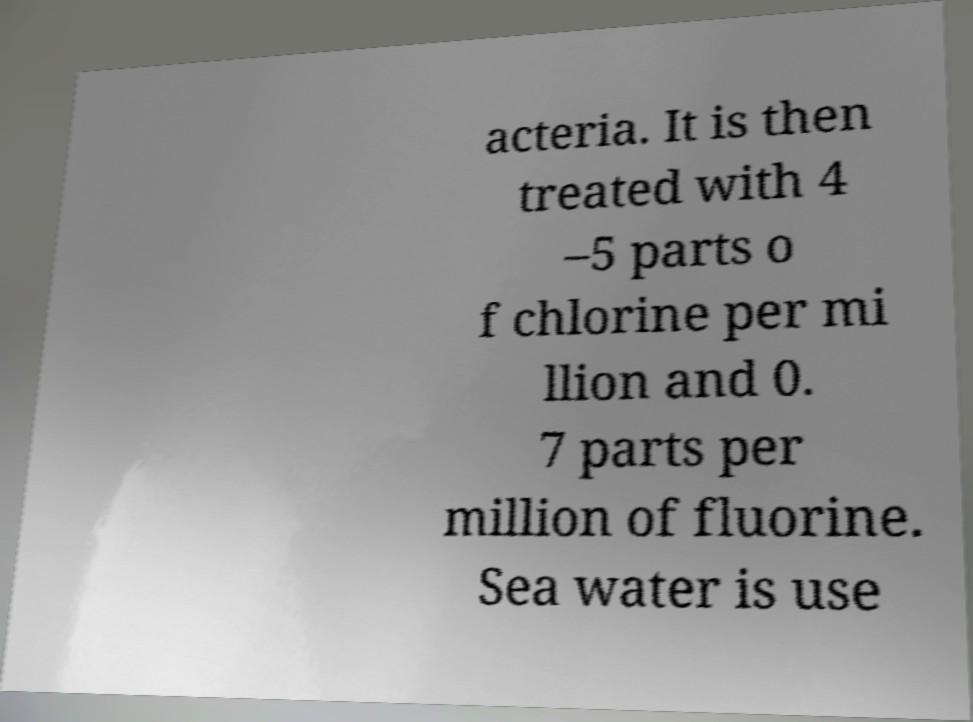Could you extract and type out the text from this image? acteria. It is then treated with 4 –5 parts o f chlorine per mi llion and 0. 7 parts per million of fluorine. Sea water is use 